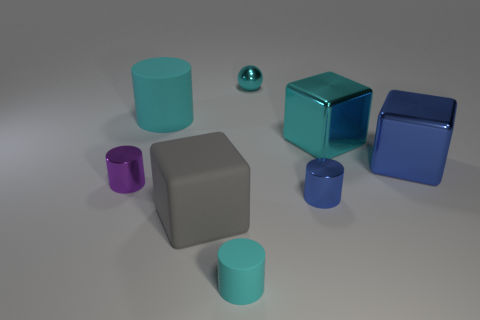Subtract all brown cylinders. Subtract all red blocks. How many cylinders are left? 4 Add 2 big green metallic balls. How many objects exist? 10 Subtract all balls. How many objects are left? 7 Subtract all purple matte balls. Subtract all tiny objects. How many objects are left? 4 Add 2 tiny balls. How many tiny balls are left? 3 Add 6 big gray rubber blocks. How many big gray rubber blocks exist? 7 Subtract 1 blue blocks. How many objects are left? 7 